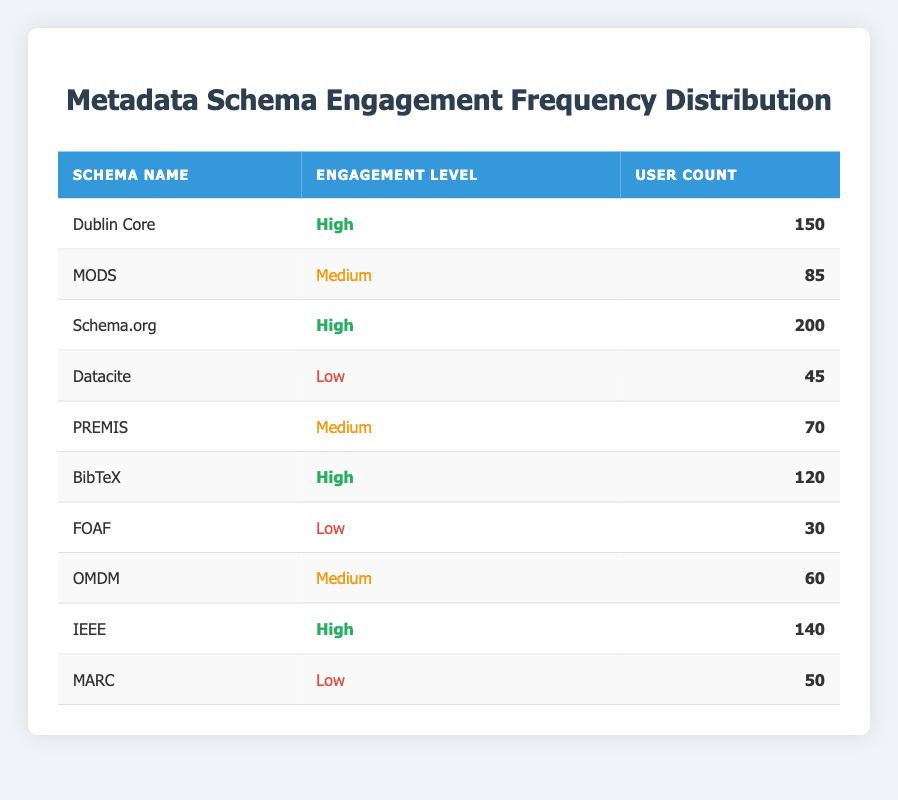What is the user count for Schema.org? The table lists Schema.org with a user count of 200.
Answer: 200 How many metadata schemas have a Low engagement level? The table lists three schemas with a Low engagement level: Datacite, FOAF, and MARC.
Answer: 3 What is the total user count for all High engagement level schemas? The total user count for High engagement level schemas (Dublin Core, Schema.org, BibTeX, and IEEE) is 150 + 200 + 120 + 140 = 610.
Answer: 610 Which schema has the highest user count? The schema with the highest user count is Schema.org, with 200 users.
Answer: Schema.org Is there a metadata schema with both High engagement and a user count over 150? Yes, Schema.org has a High engagement level and a user count of 200, which is over 150.
Answer: Yes What is the average user count for Medium engagement schemas? There are three Medium engagement schemas (MODS, PREMIS, OMDM) with user counts of 85, 70, and 60. The total is 85 + 70 + 60 = 215; the average is 215/3 = 71.67, which rounds to 72.
Answer: 72 How many schemas fall under Medium engagement with a user count less than 80? There are two Medium engagement schemas: MODS (85) and OMDM (60). Only OMDM has a user count of less than 80.
Answer: 1 What percentage of users are engaged with Low engagement schemas compared to the total user count? Low engagement schemas are Datacite (45), FOAF (30), and MARC (50), making a total of 125 users. The total user count is 150 + 85 + 200 + 45 + 70 + 120 + 30 + 60 + 140 + 50 = 950. The percentage of Low engagement users is (125/950) * 100 = 13.16%.
Answer: 13.16% Which engagement level has the most schemas associated with it? The Medium engagement level has three schemas (MODS, PREMIS, and OMDM), while High and Low each have four and three schemas respectively. Hence, Medium engagement level is tied with Low in terms of number of schemas.
Answer: Medium (3) and Low (3) 